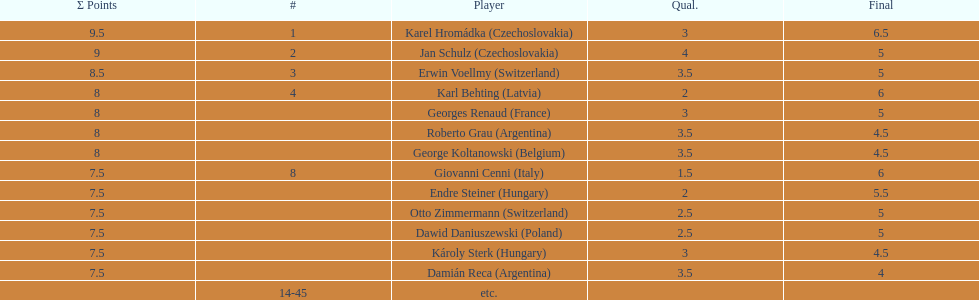How many participants scored 8 points? 4. 